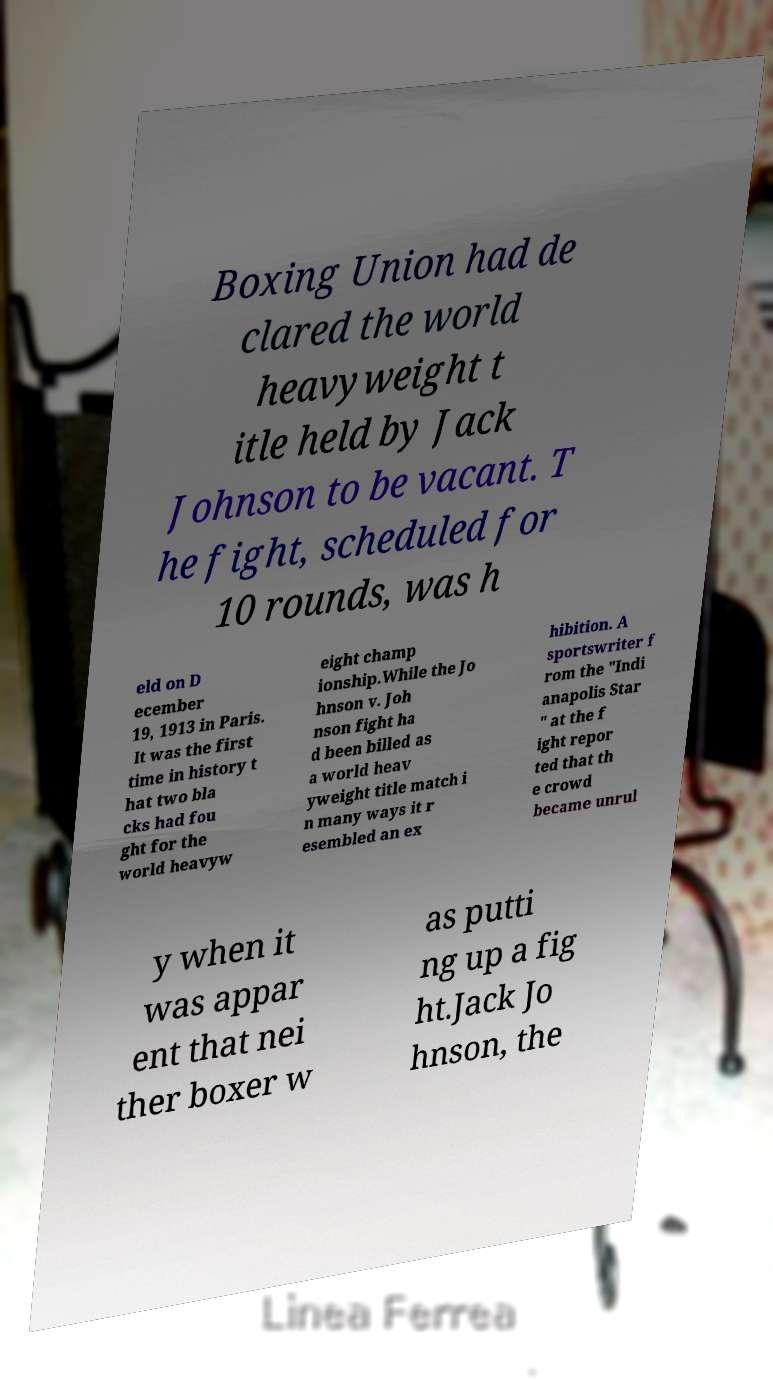What messages or text are displayed in this image? I need them in a readable, typed format. Boxing Union had de clared the world heavyweight t itle held by Jack Johnson to be vacant. T he fight, scheduled for 10 rounds, was h eld on D ecember 19, 1913 in Paris. It was the first time in history t hat two bla cks had fou ght for the world heavyw eight champ ionship.While the Jo hnson v. Joh nson fight ha d been billed as a world heav yweight title match i n many ways it r esembled an ex hibition. A sportswriter f rom the "Indi anapolis Star " at the f ight repor ted that th e crowd became unrul y when it was appar ent that nei ther boxer w as putti ng up a fig ht.Jack Jo hnson, the 